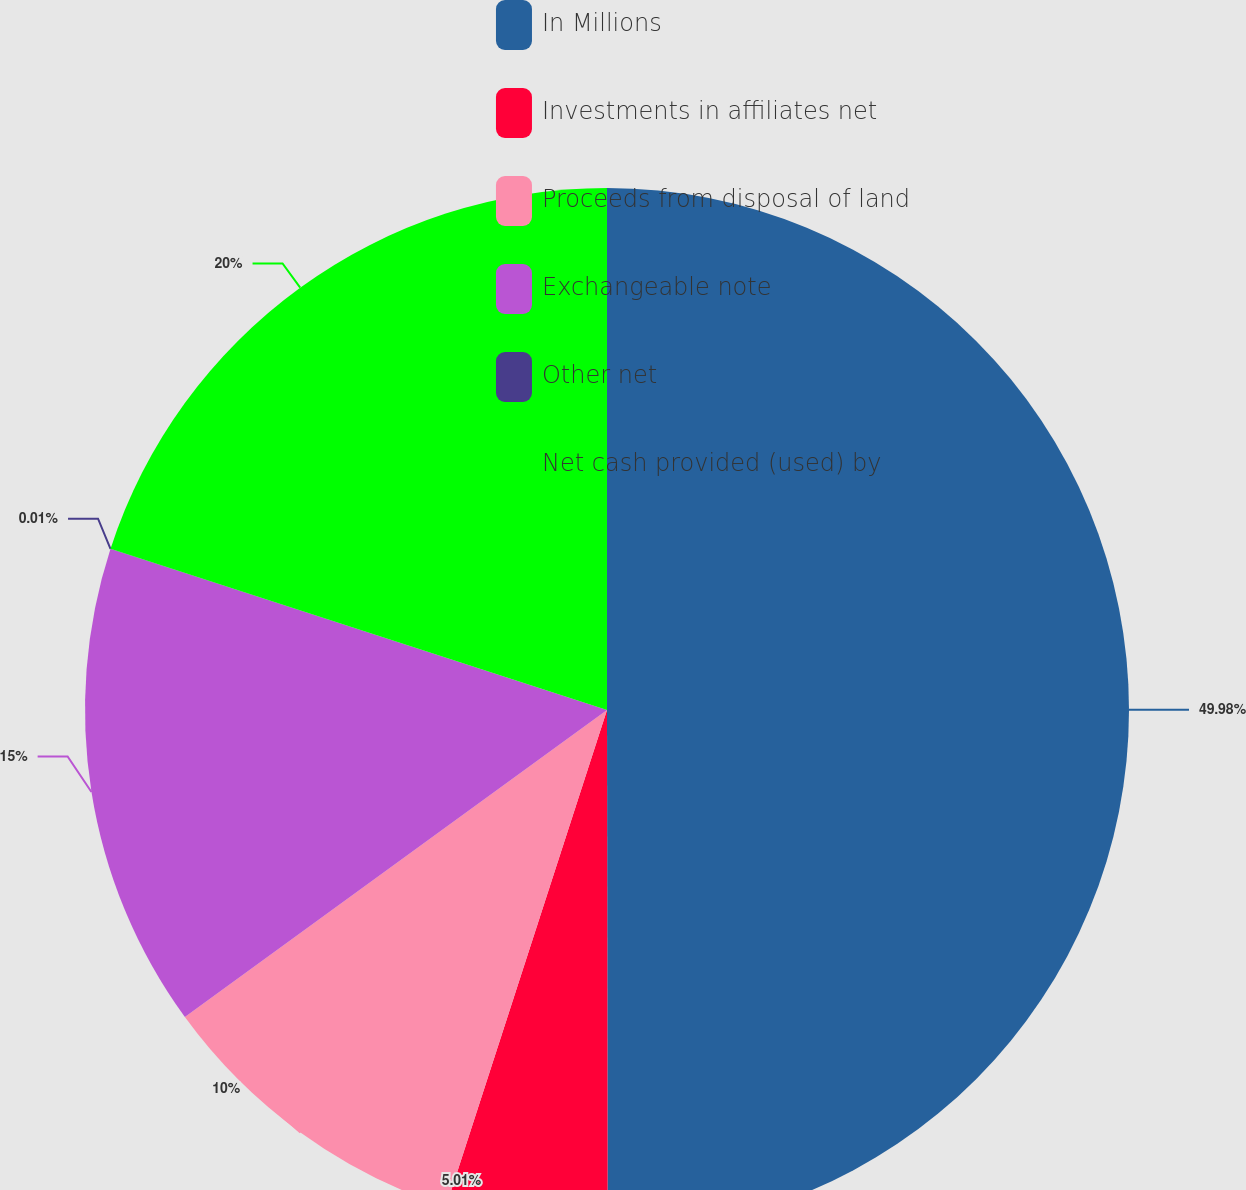Convert chart. <chart><loc_0><loc_0><loc_500><loc_500><pie_chart><fcel>In Millions<fcel>Investments in affiliates net<fcel>Proceeds from disposal of land<fcel>Exchangeable note<fcel>Other net<fcel>Net cash provided (used) by<nl><fcel>49.98%<fcel>5.01%<fcel>10.0%<fcel>15.0%<fcel>0.01%<fcel>20.0%<nl></chart> 